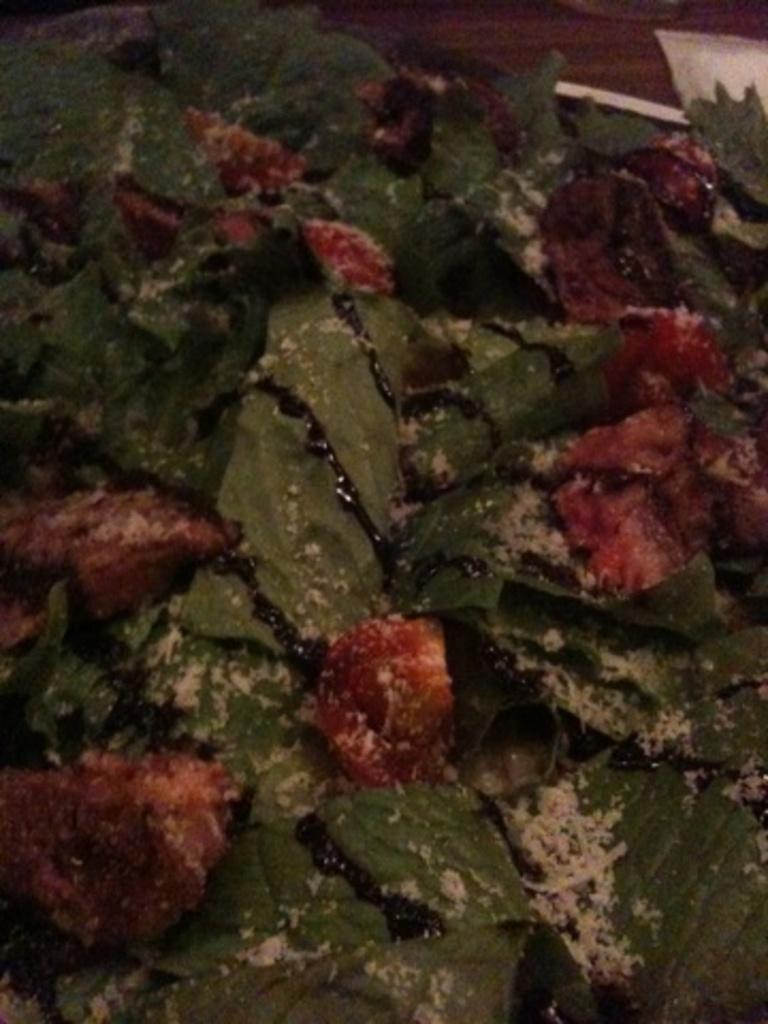Can you describe this image briefly? As we can see in the image there are leaves and red color fruits here and there. 